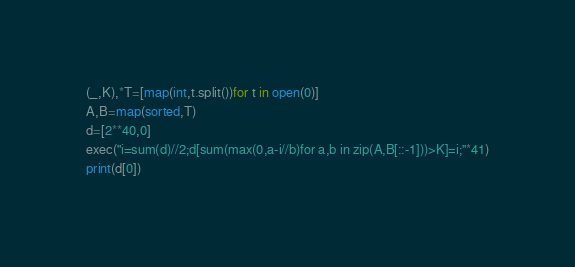<code> <loc_0><loc_0><loc_500><loc_500><_Python_>(_,K),*T=[map(int,t.split())for t in open(0)]
A,B=map(sorted,T)
d=[2**40,0]
exec("i=sum(d)//2;d[sum(max(0,a-i//b)for a,b in zip(A,B[::-1]))>K]=i;"*41)
print(d[0])</code> 